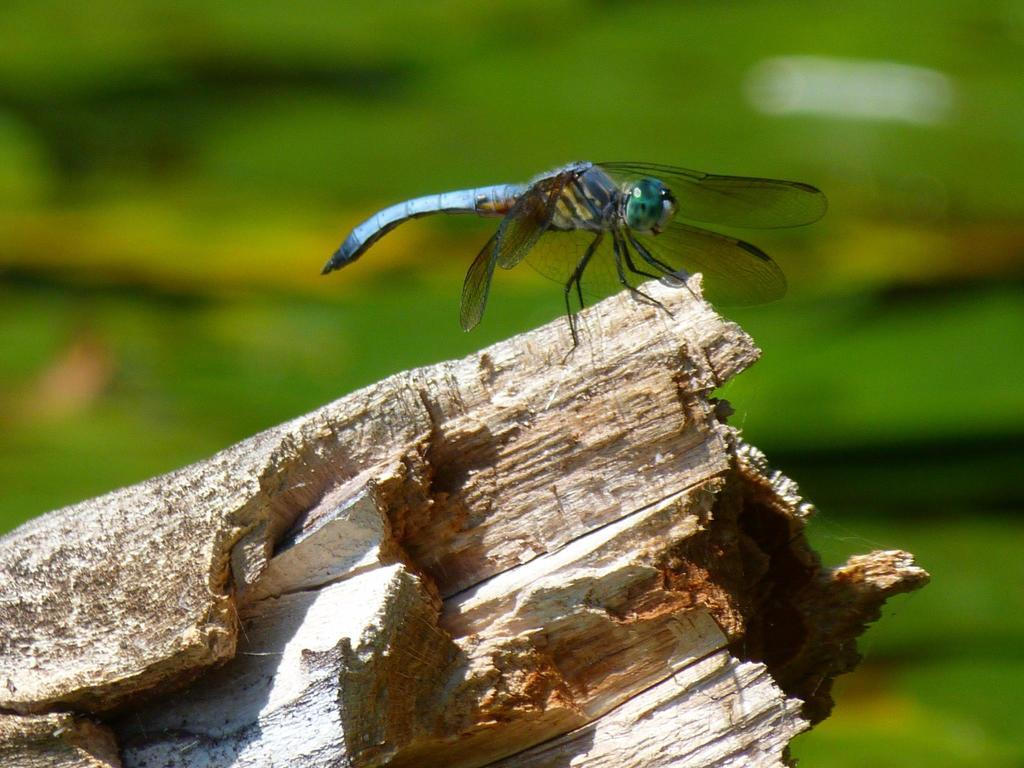What type of insect is in the image? There is a blue-colored insect in the image. What color is the background of the image? The background of the image is green. How would you describe the quality of the image in the background? The image is blurry in the background. What type of pot is on the shelf in the image? There is no shelf or pot present in the image; it features a blue-colored insect against a green background. 